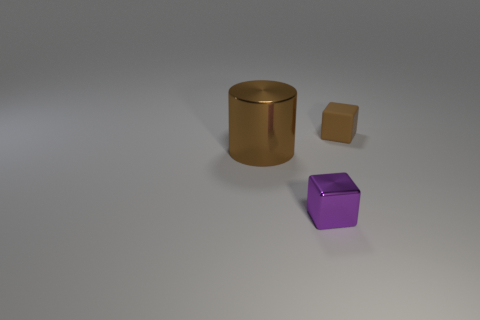Add 3 tiny rubber blocks. How many objects exist? 6 Subtract all purple cubes. How many cubes are left? 1 Subtract all yellow blocks. How many yellow cylinders are left? 0 Add 1 brown shiny cylinders. How many brown shiny cylinders exist? 2 Subtract 1 brown cylinders. How many objects are left? 2 Subtract all cylinders. How many objects are left? 2 Subtract all blue cylinders. Subtract all green blocks. How many cylinders are left? 1 Subtract all large brown cylinders. Subtract all tiny purple shiny cubes. How many objects are left? 1 Add 1 large brown cylinders. How many large brown cylinders are left? 2 